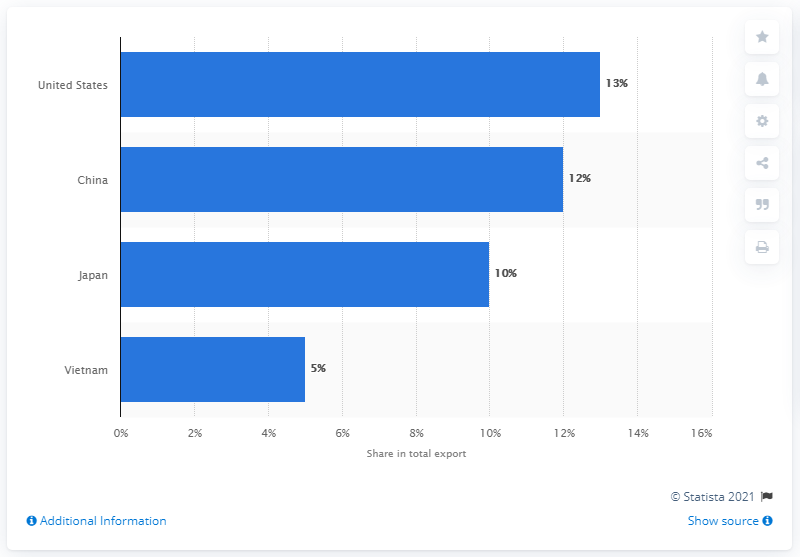Identify some key points in this picture. In 2019, the United States was Thailand's most important export partner. 